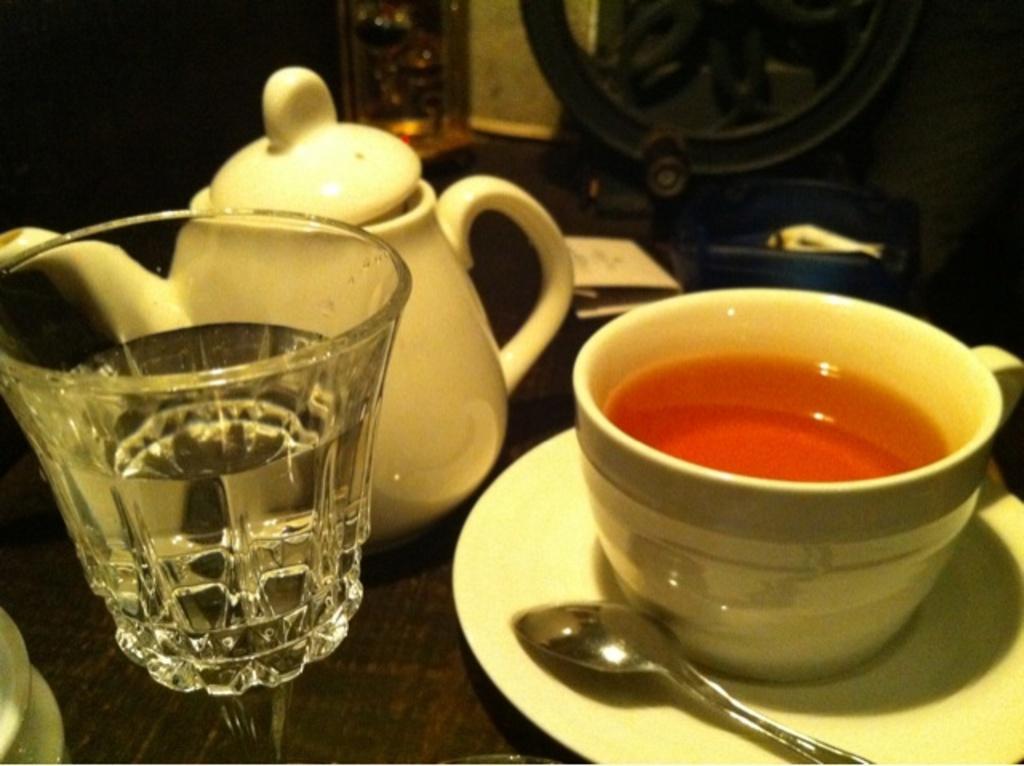How would you summarize this image in a sentence or two? In the picture there is a glass with water and a tea pot and a cup filled with some drink is kept on a saucer,all these are placed on a table. 